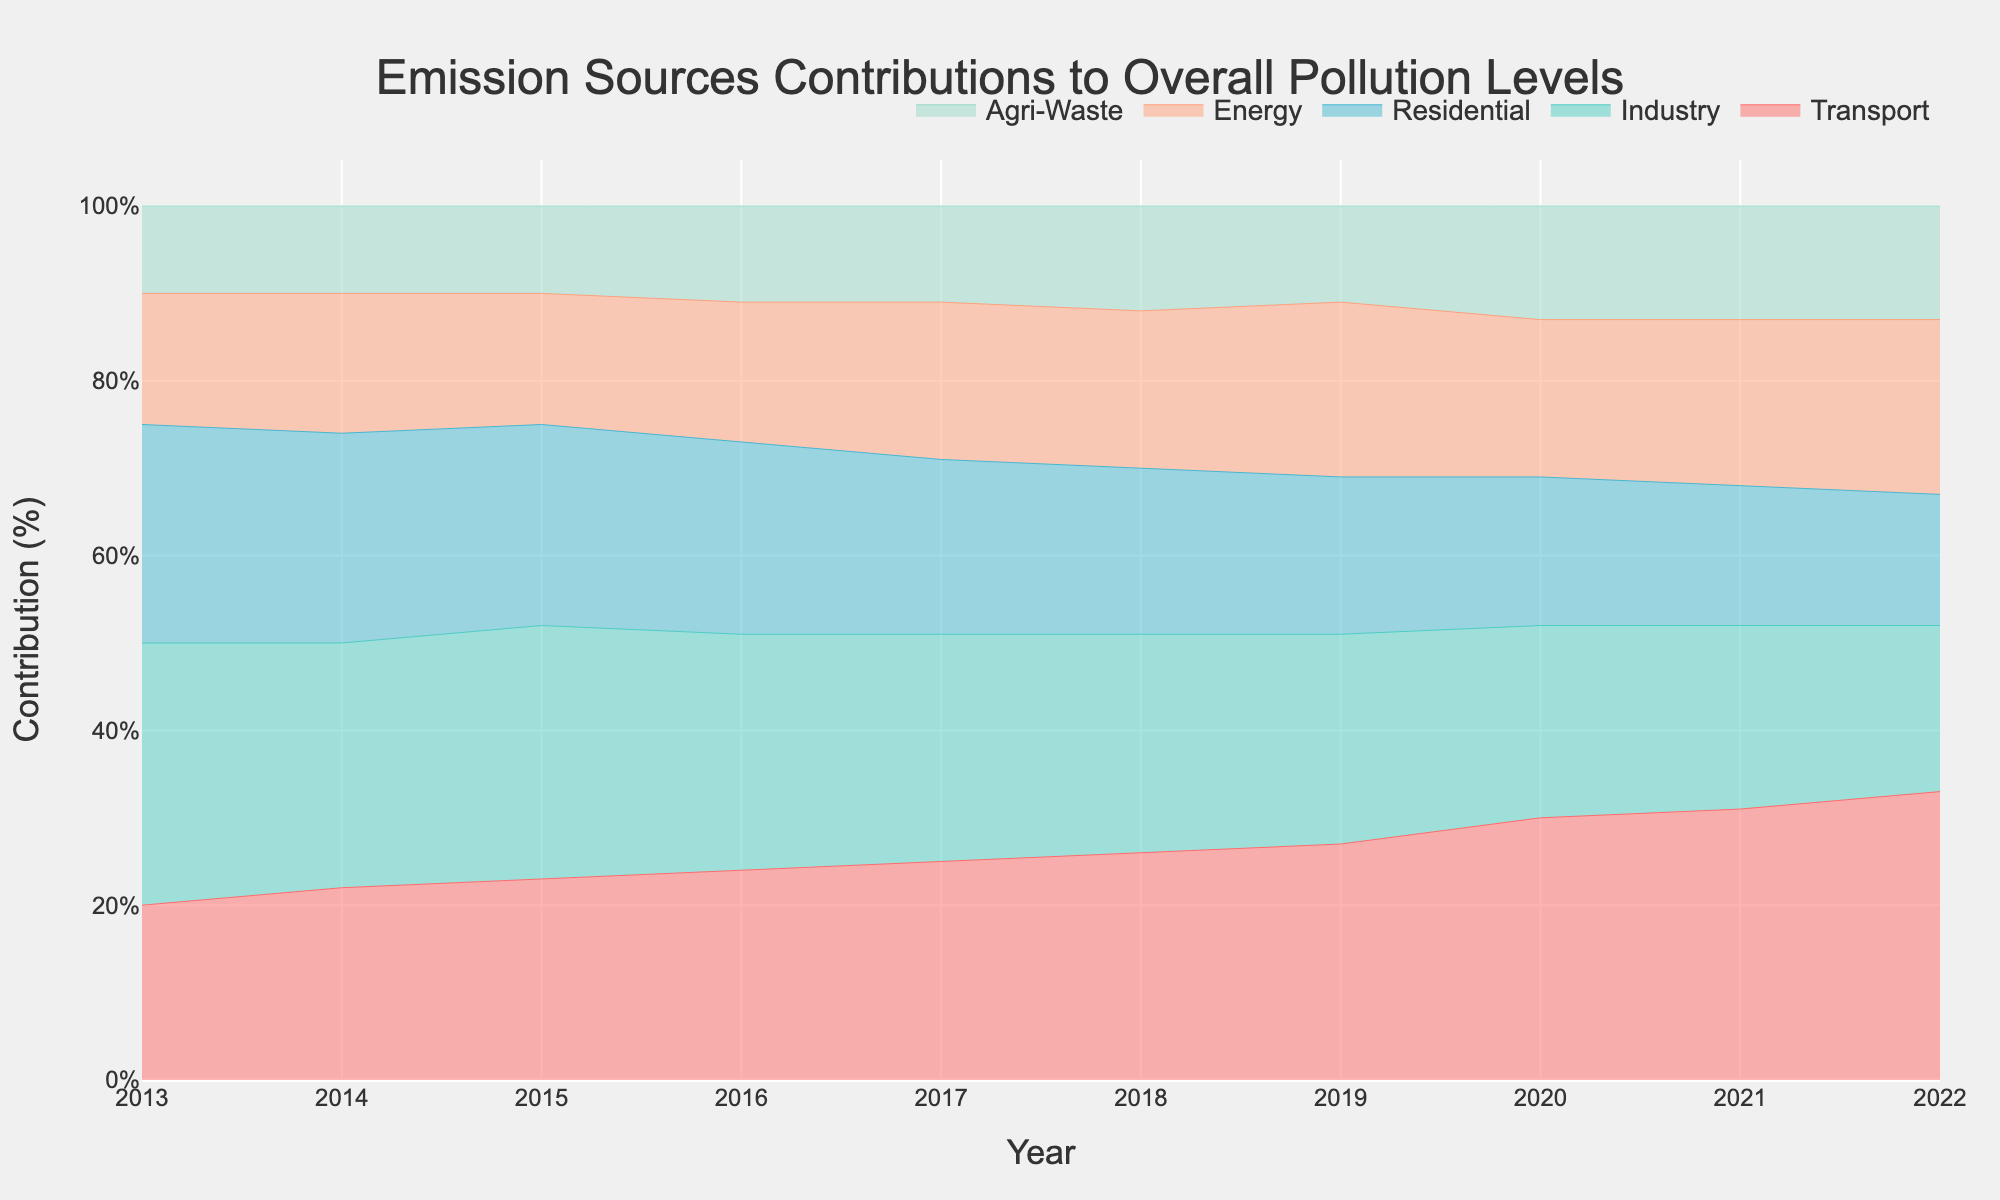What is the title of the graph? The title of the graph is typically displayed at the top center of the figure for easy identification.
Answer: Emission Sources Contributions to Overall Pollution Levels Over the Past Decade What is the source contributing the highest percentage in 2022? In 2022, observe the segments of the stream graph at the endpoint of the x-axis marked 2022. The largest segment corresponds to the category with the highest percentage.
Answer: Transport Which source has decreased its contribution the most between 2013 and 2022? By comparing the sizes of the segments from 2013 to 2022 for each source, you will notice the largest reduction for the source that shows the most substantial shrinkage.
Answer: Industry How did the Residential sector's contribution change over the decade? Track the Residential sector's segment from 2013 to 2022 and observe if it generally increases, decreases, or remains steady.
Answer: Decreased What is the total contribution percentage of Energy and Agri-Waste sectors combined in 2020? Find the percentage contributions of Energy and Agri-Waste in 2020 by looking at the respective segments, then sum these percentages.
Answer: 31% Which year shows the peak contribution from the Transport sector? Identify the year where the Transport sector's stream segment reaches its highest point throughout the graph.
Answer: 2022 Compare the contributions of Energy in 2017 and 2022. Which year had a higher contribution? Locate and compare the segment sizes for the Energy sector in 2017 and 2022 to determine which is larger.
Answer: 2022 By how many percentage points did the Transport sector's contribution increase from 2013 to 2022? Subtract the Transport sector's percentage in 2013 from its percentage in 2022 to find the difference.
Answer: 13 In which year did the Agri-Waste sector show no change compared to the previous year? Look at the segments of the Agri-Waste sector over the years and identify the years where two consecutive segments have the same size.
Answer: 2014 Between which years did the Industry sector see the largest year-to-year drop in contribution? Examine the year-to-year differences in the Industry sector's segment size and identify the largest decrease.
Answer: 2019 to 2020 